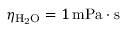<formula> <loc_0><loc_0><loc_500><loc_500>\eta _ { H _ { 2 } O } = 1 \, m P a \cdot s</formula> 